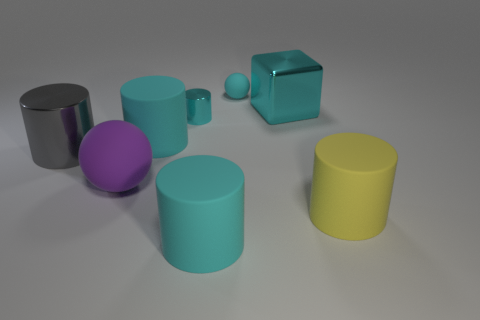Subtract all cyan cylinders. How many were subtracted if there are1cyan cylinders left? 2 Subtract all purple cubes. How many cyan cylinders are left? 3 Subtract 1 cylinders. How many cylinders are left? 4 Subtract all gray cylinders. How many cylinders are left? 4 Subtract all brown cylinders. Subtract all brown blocks. How many cylinders are left? 5 Add 2 purple cylinders. How many objects exist? 10 Subtract all cubes. How many objects are left? 7 Add 1 big yellow cylinders. How many big yellow cylinders exist? 2 Subtract 0 red spheres. How many objects are left? 8 Subtract all purple objects. Subtract all big rubber balls. How many objects are left? 6 